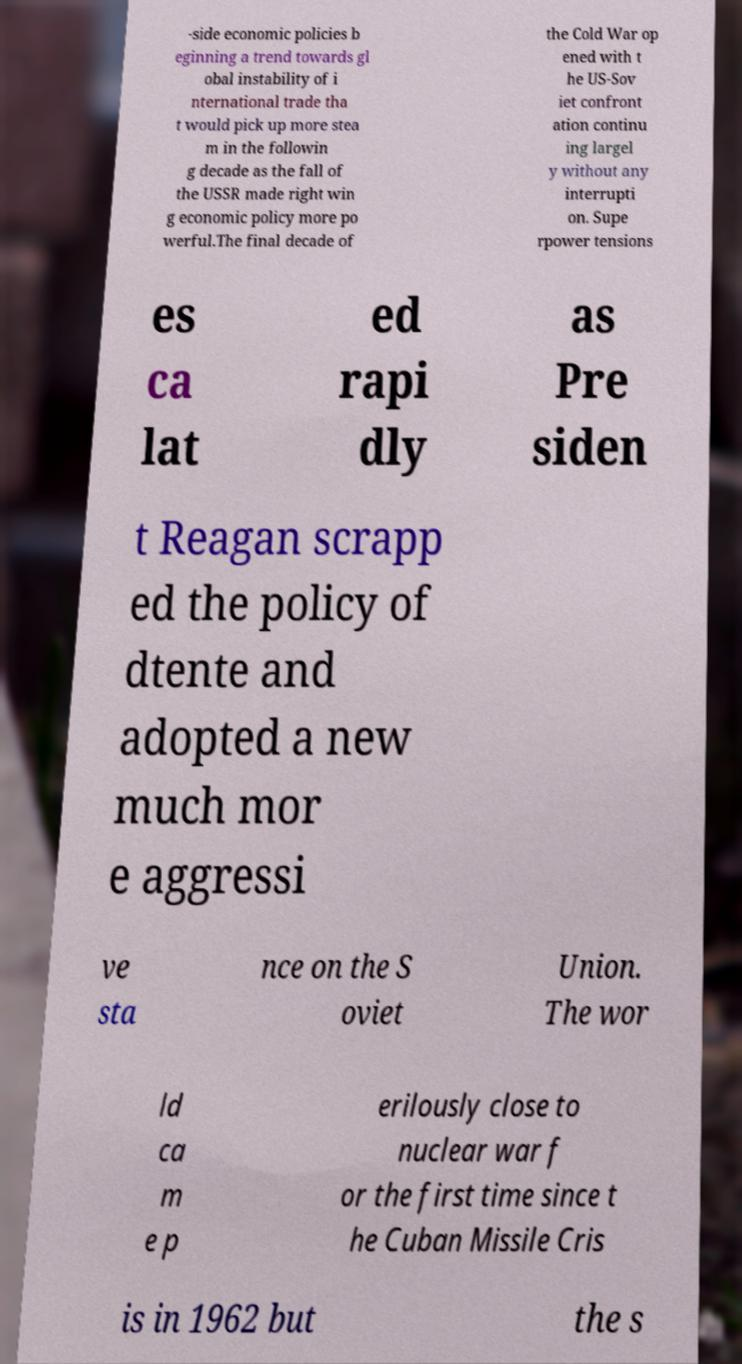For documentation purposes, I need the text within this image transcribed. Could you provide that? -side economic policies b eginning a trend towards gl obal instability of i nternational trade tha t would pick up more stea m in the followin g decade as the fall of the USSR made right win g economic policy more po werful.The final decade of the Cold War op ened with t he US-Sov iet confront ation continu ing largel y without any interrupti on. Supe rpower tensions es ca lat ed rapi dly as Pre siden t Reagan scrapp ed the policy of dtente and adopted a new much mor e aggressi ve sta nce on the S oviet Union. The wor ld ca m e p erilously close to nuclear war f or the first time since t he Cuban Missile Cris is in 1962 but the s 